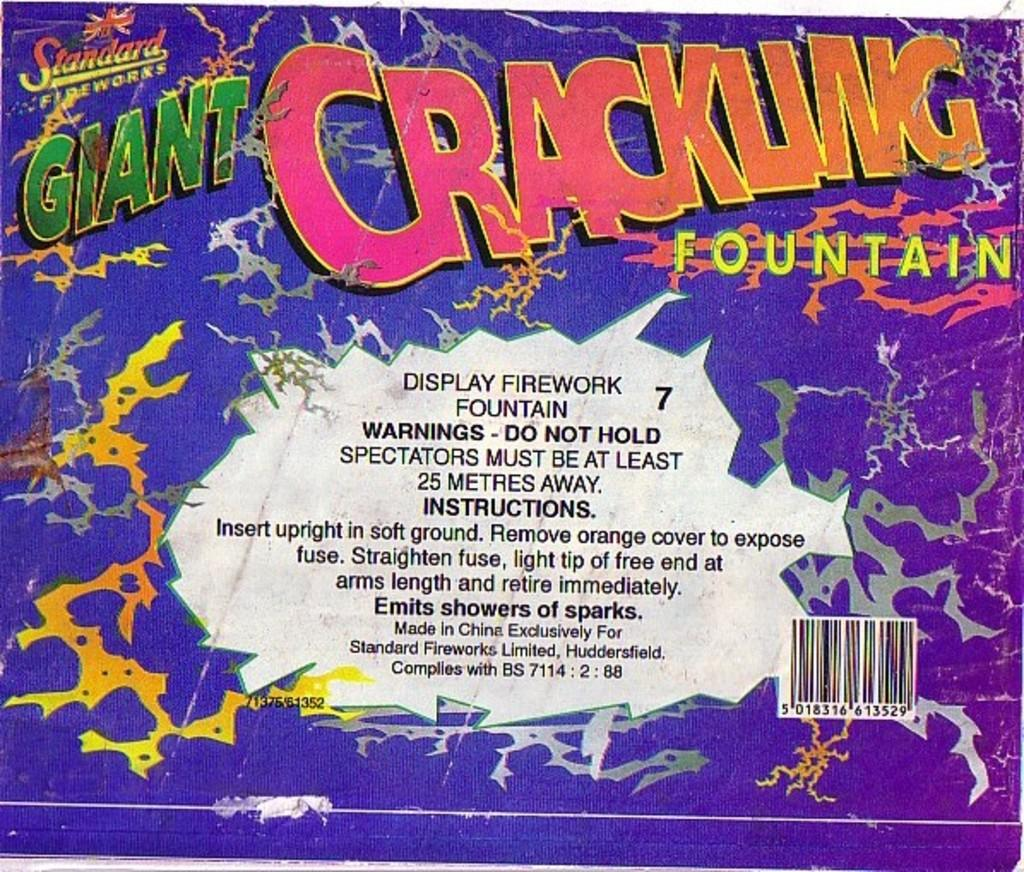<image>
Create a compact narrative representing the image presented. the back of an item that says 'giant crackling fountain' 